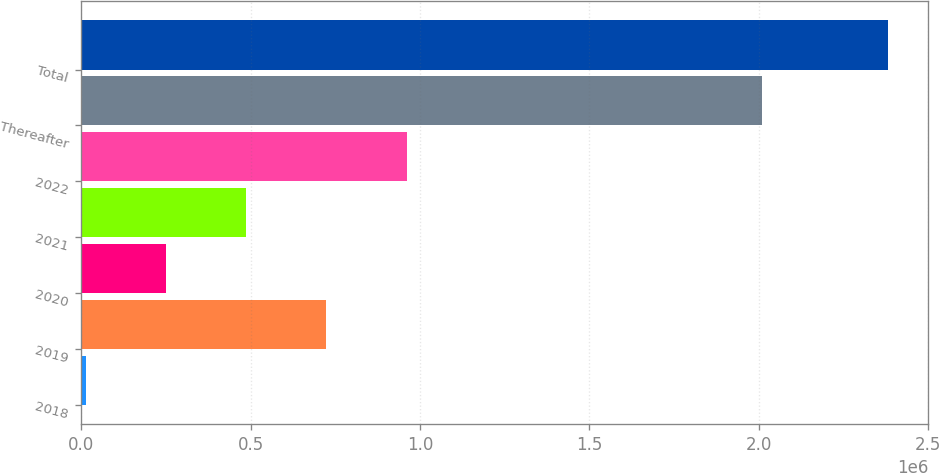<chart> <loc_0><loc_0><loc_500><loc_500><bar_chart><fcel>2018<fcel>2019<fcel>2020<fcel>2021<fcel>2022<fcel>Thereafter<fcel>Total<nl><fcel>12491<fcel>723123<fcel>249368<fcel>486245<fcel>960000<fcel>2.0091e+06<fcel>2.38126e+06<nl></chart> 